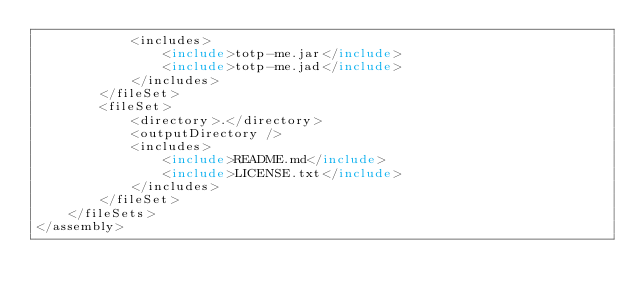<code> <loc_0><loc_0><loc_500><loc_500><_XML_>			<includes>
				<include>totp-me.jar</include>
				<include>totp-me.jad</include>
			</includes>
		</fileSet>
		<fileSet>
			<directory>.</directory>
			<outputDirectory />
			<includes>
				<include>README.md</include>
				<include>LICENSE.txt</include>
			</includes>
		</fileSet>
	</fileSets>
</assembly>
</code> 